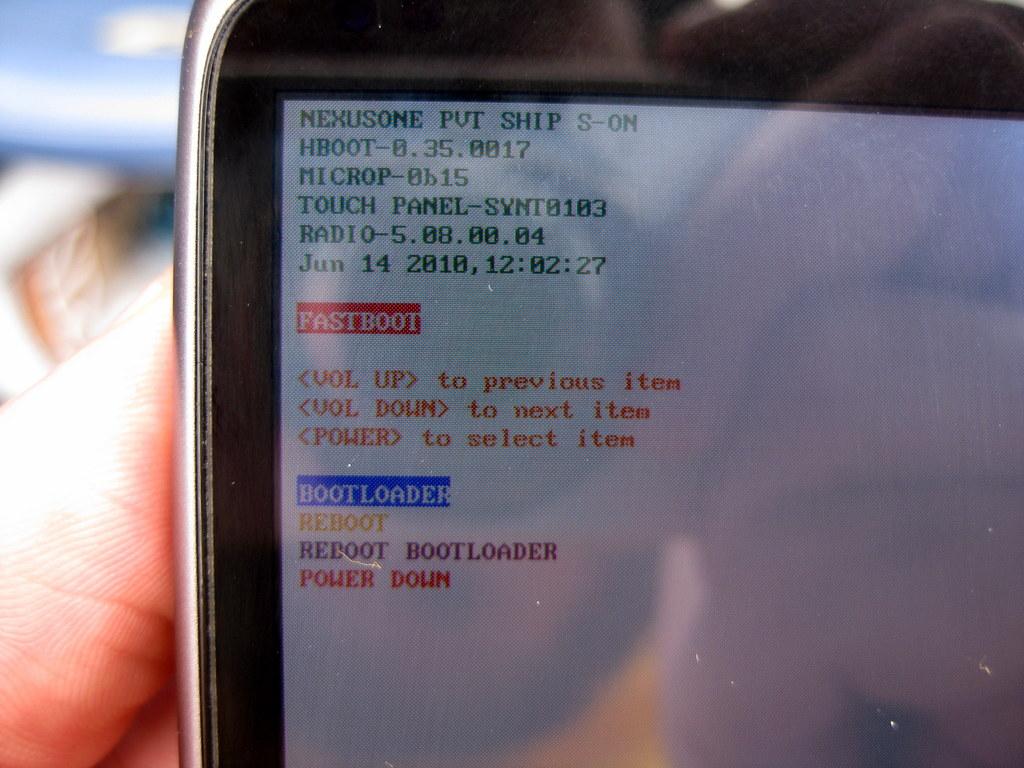What date is shown?
Keep it short and to the point. June 14 2010. 